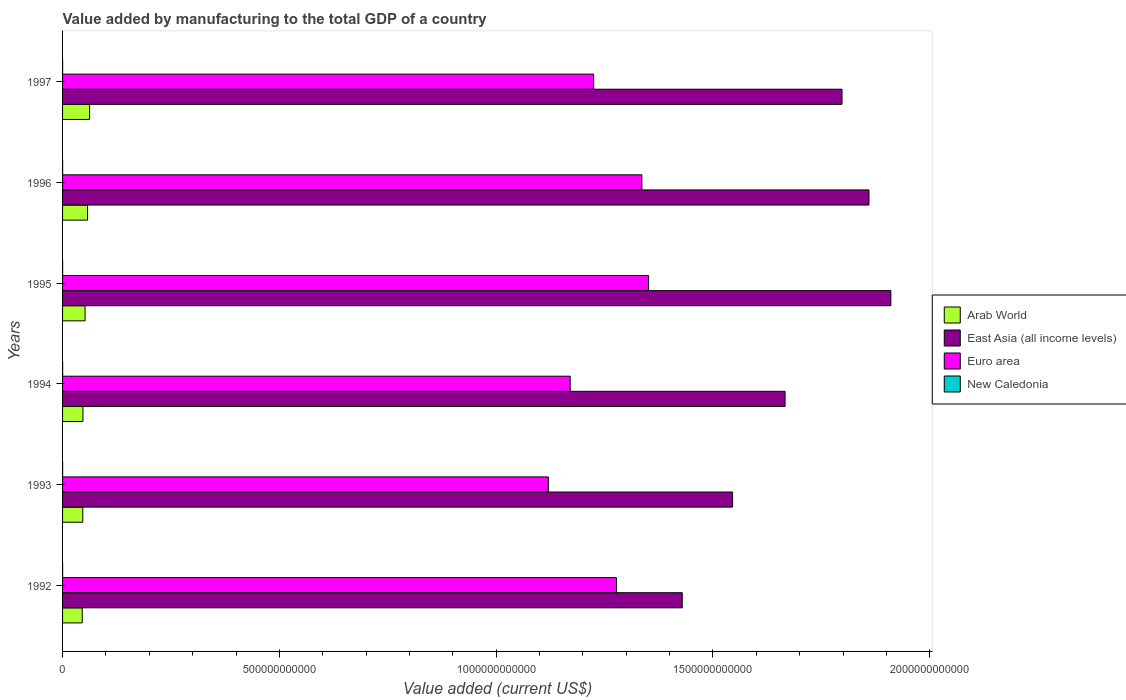How many different coloured bars are there?
Give a very brief answer. 4. How many groups of bars are there?
Offer a terse response. 6. Are the number of bars per tick equal to the number of legend labels?
Provide a short and direct response. Yes. How many bars are there on the 1st tick from the bottom?
Offer a terse response. 4. What is the label of the 1st group of bars from the top?
Your response must be concise. 1997. In how many cases, is the number of bars for a given year not equal to the number of legend labels?
Your answer should be very brief. 0. What is the value added by manufacturing to the total GDP in New Caledonia in 1995?
Give a very brief answer. 1.53e+08. Across all years, what is the maximum value added by manufacturing to the total GDP in New Caledonia?
Your response must be concise. 1.53e+08. Across all years, what is the minimum value added by manufacturing to the total GDP in East Asia (all income levels)?
Provide a short and direct response. 1.43e+12. In which year was the value added by manufacturing to the total GDP in Euro area maximum?
Offer a terse response. 1995. In which year was the value added by manufacturing to the total GDP in Arab World minimum?
Ensure brevity in your answer.  1992. What is the total value added by manufacturing to the total GDP in Arab World in the graph?
Your answer should be very brief. 3.11e+11. What is the difference between the value added by manufacturing to the total GDP in East Asia (all income levels) in 1995 and that in 1997?
Give a very brief answer. 1.13e+11. What is the difference between the value added by manufacturing to the total GDP in New Caledonia in 1993 and the value added by manufacturing to the total GDP in Euro area in 1995?
Keep it short and to the point. -1.35e+12. What is the average value added by manufacturing to the total GDP in Arab World per year?
Make the answer very short. 5.18e+1. In the year 1995, what is the difference between the value added by manufacturing to the total GDP in Arab World and value added by manufacturing to the total GDP in East Asia (all income levels)?
Provide a short and direct response. -1.86e+12. What is the ratio of the value added by manufacturing to the total GDP in East Asia (all income levels) in 1996 to that in 1997?
Offer a very short reply. 1.03. Is the difference between the value added by manufacturing to the total GDP in Arab World in 1995 and 1997 greater than the difference between the value added by manufacturing to the total GDP in East Asia (all income levels) in 1995 and 1997?
Ensure brevity in your answer.  No. What is the difference between the highest and the second highest value added by manufacturing to the total GDP in Arab World?
Your answer should be very brief. 4.71e+09. What is the difference between the highest and the lowest value added by manufacturing to the total GDP in East Asia (all income levels)?
Your answer should be very brief. 4.81e+11. In how many years, is the value added by manufacturing to the total GDP in Arab World greater than the average value added by manufacturing to the total GDP in Arab World taken over all years?
Give a very brief answer. 3. Is the sum of the value added by manufacturing to the total GDP in Arab World in 1993 and 1995 greater than the maximum value added by manufacturing to the total GDP in East Asia (all income levels) across all years?
Make the answer very short. No. What does the 3rd bar from the top in 1995 represents?
Provide a short and direct response. East Asia (all income levels). What does the 2nd bar from the bottom in 1997 represents?
Make the answer very short. East Asia (all income levels). Are all the bars in the graph horizontal?
Your answer should be very brief. Yes. What is the difference between two consecutive major ticks on the X-axis?
Give a very brief answer. 5.00e+11. Are the values on the major ticks of X-axis written in scientific E-notation?
Your answer should be compact. No. Does the graph contain any zero values?
Make the answer very short. No. Does the graph contain grids?
Provide a succinct answer. No. What is the title of the graph?
Make the answer very short. Value added by manufacturing to the total GDP of a country. What is the label or title of the X-axis?
Offer a terse response. Value added (current US$). What is the label or title of the Y-axis?
Offer a very short reply. Years. What is the Value added (current US$) in Arab World in 1992?
Your response must be concise. 4.54e+1. What is the Value added (current US$) in East Asia (all income levels) in 1992?
Offer a very short reply. 1.43e+12. What is the Value added (current US$) of Euro area in 1992?
Offer a very short reply. 1.28e+12. What is the Value added (current US$) of New Caledonia in 1992?
Make the answer very short. 1.42e+08. What is the Value added (current US$) in Arab World in 1993?
Keep it short and to the point. 4.66e+1. What is the Value added (current US$) in East Asia (all income levels) in 1993?
Give a very brief answer. 1.55e+12. What is the Value added (current US$) of Euro area in 1993?
Offer a very short reply. 1.12e+12. What is the Value added (current US$) of New Caledonia in 1993?
Provide a short and direct response. 1.44e+08. What is the Value added (current US$) in Arab World in 1994?
Make the answer very short. 4.70e+1. What is the Value added (current US$) in East Asia (all income levels) in 1994?
Your answer should be compact. 1.67e+12. What is the Value added (current US$) in Euro area in 1994?
Keep it short and to the point. 1.17e+12. What is the Value added (current US$) in New Caledonia in 1994?
Give a very brief answer. 1.40e+08. What is the Value added (current US$) in Arab World in 1995?
Keep it short and to the point. 5.19e+1. What is the Value added (current US$) in East Asia (all income levels) in 1995?
Provide a succinct answer. 1.91e+12. What is the Value added (current US$) of Euro area in 1995?
Make the answer very short. 1.35e+12. What is the Value added (current US$) in New Caledonia in 1995?
Your answer should be compact. 1.53e+08. What is the Value added (current US$) of Arab World in 1996?
Provide a short and direct response. 5.77e+1. What is the Value added (current US$) of East Asia (all income levels) in 1996?
Offer a very short reply. 1.86e+12. What is the Value added (current US$) of Euro area in 1996?
Keep it short and to the point. 1.34e+12. What is the Value added (current US$) in New Caledonia in 1996?
Provide a short and direct response. 1.43e+08. What is the Value added (current US$) in Arab World in 1997?
Your answer should be very brief. 6.24e+1. What is the Value added (current US$) in East Asia (all income levels) in 1997?
Offer a terse response. 1.80e+12. What is the Value added (current US$) of Euro area in 1997?
Give a very brief answer. 1.22e+12. What is the Value added (current US$) in New Caledonia in 1997?
Give a very brief answer. 1.30e+08. Across all years, what is the maximum Value added (current US$) of Arab World?
Provide a short and direct response. 6.24e+1. Across all years, what is the maximum Value added (current US$) in East Asia (all income levels)?
Your answer should be very brief. 1.91e+12. Across all years, what is the maximum Value added (current US$) of Euro area?
Provide a short and direct response. 1.35e+12. Across all years, what is the maximum Value added (current US$) of New Caledonia?
Offer a very short reply. 1.53e+08. Across all years, what is the minimum Value added (current US$) of Arab World?
Your response must be concise. 4.54e+1. Across all years, what is the minimum Value added (current US$) in East Asia (all income levels)?
Make the answer very short. 1.43e+12. Across all years, what is the minimum Value added (current US$) of Euro area?
Provide a succinct answer. 1.12e+12. Across all years, what is the minimum Value added (current US$) in New Caledonia?
Make the answer very short. 1.30e+08. What is the total Value added (current US$) of Arab World in the graph?
Your response must be concise. 3.11e+11. What is the total Value added (current US$) of East Asia (all income levels) in the graph?
Give a very brief answer. 1.02e+13. What is the total Value added (current US$) in Euro area in the graph?
Offer a terse response. 7.48e+12. What is the total Value added (current US$) of New Caledonia in the graph?
Ensure brevity in your answer.  8.52e+08. What is the difference between the Value added (current US$) of Arab World in 1992 and that in 1993?
Keep it short and to the point. -1.29e+09. What is the difference between the Value added (current US$) in East Asia (all income levels) in 1992 and that in 1993?
Provide a short and direct response. -1.16e+11. What is the difference between the Value added (current US$) in Euro area in 1992 and that in 1993?
Ensure brevity in your answer.  1.57e+11. What is the difference between the Value added (current US$) of New Caledonia in 1992 and that in 1993?
Offer a terse response. -2.42e+06. What is the difference between the Value added (current US$) in Arab World in 1992 and that in 1994?
Give a very brief answer. -1.65e+09. What is the difference between the Value added (current US$) in East Asia (all income levels) in 1992 and that in 1994?
Make the answer very short. -2.37e+11. What is the difference between the Value added (current US$) of Euro area in 1992 and that in 1994?
Offer a terse response. 1.07e+11. What is the difference between the Value added (current US$) of New Caledonia in 1992 and that in 1994?
Your answer should be very brief. 1.45e+06. What is the difference between the Value added (current US$) in Arab World in 1992 and that in 1995?
Make the answer very short. -6.56e+09. What is the difference between the Value added (current US$) in East Asia (all income levels) in 1992 and that in 1995?
Provide a short and direct response. -4.81e+11. What is the difference between the Value added (current US$) in Euro area in 1992 and that in 1995?
Your response must be concise. -7.39e+1. What is the difference between the Value added (current US$) in New Caledonia in 1992 and that in 1995?
Provide a succinct answer. -1.15e+07. What is the difference between the Value added (current US$) of Arab World in 1992 and that in 1996?
Your answer should be very brief. -1.23e+1. What is the difference between the Value added (current US$) of East Asia (all income levels) in 1992 and that in 1996?
Keep it short and to the point. -4.31e+11. What is the difference between the Value added (current US$) of Euro area in 1992 and that in 1996?
Your answer should be compact. -5.85e+1. What is the difference between the Value added (current US$) of New Caledonia in 1992 and that in 1996?
Make the answer very short. -1.44e+06. What is the difference between the Value added (current US$) of Arab World in 1992 and that in 1997?
Give a very brief answer. -1.70e+1. What is the difference between the Value added (current US$) in East Asia (all income levels) in 1992 and that in 1997?
Give a very brief answer. -3.68e+11. What is the difference between the Value added (current US$) in Euro area in 1992 and that in 1997?
Give a very brief answer. 5.28e+1. What is the difference between the Value added (current US$) in New Caledonia in 1992 and that in 1997?
Offer a terse response. 1.13e+07. What is the difference between the Value added (current US$) of Arab World in 1993 and that in 1994?
Offer a very short reply. -3.62e+08. What is the difference between the Value added (current US$) in East Asia (all income levels) in 1993 and that in 1994?
Your response must be concise. -1.21e+11. What is the difference between the Value added (current US$) in Euro area in 1993 and that in 1994?
Offer a very short reply. -5.04e+1. What is the difference between the Value added (current US$) in New Caledonia in 1993 and that in 1994?
Your response must be concise. 3.86e+06. What is the difference between the Value added (current US$) of Arab World in 1993 and that in 1995?
Your answer should be compact. -5.28e+09. What is the difference between the Value added (current US$) of East Asia (all income levels) in 1993 and that in 1995?
Your response must be concise. -3.65e+11. What is the difference between the Value added (current US$) of Euro area in 1993 and that in 1995?
Make the answer very short. -2.31e+11. What is the difference between the Value added (current US$) of New Caledonia in 1993 and that in 1995?
Your response must be concise. -9.07e+06. What is the difference between the Value added (current US$) in Arab World in 1993 and that in 1996?
Your answer should be very brief. -1.10e+1. What is the difference between the Value added (current US$) of East Asia (all income levels) in 1993 and that in 1996?
Provide a succinct answer. -3.14e+11. What is the difference between the Value added (current US$) of Euro area in 1993 and that in 1996?
Offer a very short reply. -2.16e+11. What is the difference between the Value added (current US$) of New Caledonia in 1993 and that in 1996?
Make the answer very short. 9.72e+05. What is the difference between the Value added (current US$) of Arab World in 1993 and that in 1997?
Provide a succinct answer. -1.57e+1. What is the difference between the Value added (current US$) of East Asia (all income levels) in 1993 and that in 1997?
Offer a terse response. -2.52e+11. What is the difference between the Value added (current US$) in Euro area in 1993 and that in 1997?
Provide a succinct answer. -1.04e+11. What is the difference between the Value added (current US$) in New Caledonia in 1993 and that in 1997?
Give a very brief answer. 1.38e+07. What is the difference between the Value added (current US$) of Arab World in 1994 and that in 1995?
Provide a short and direct response. -4.92e+09. What is the difference between the Value added (current US$) of East Asia (all income levels) in 1994 and that in 1995?
Your response must be concise. -2.44e+11. What is the difference between the Value added (current US$) of Euro area in 1994 and that in 1995?
Provide a succinct answer. -1.81e+11. What is the difference between the Value added (current US$) of New Caledonia in 1994 and that in 1995?
Your response must be concise. -1.29e+07. What is the difference between the Value added (current US$) in Arab World in 1994 and that in 1996?
Your response must be concise. -1.07e+1. What is the difference between the Value added (current US$) of East Asia (all income levels) in 1994 and that in 1996?
Provide a short and direct response. -1.93e+11. What is the difference between the Value added (current US$) of Euro area in 1994 and that in 1996?
Make the answer very short. -1.65e+11. What is the difference between the Value added (current US$) in New Caledonia in 1994 and that in 1996?
Provide a succinct answer. -2.89e+06. What is the difference between the Value added (current US$) in Arab World in 1994 and that in 1997?
Your answer should be very brief. -1.54e+1. What is the difference between the Value added (current US$) in East Asia (all income levels) in 1994 and that in 1997?
Ensure brevity in your answer.  -1.31e+11. What is the difference between the Value added (current US$) of Euro area in 1994 and that in 1997?
Your answer should be very brief. -5.40e+1. What is the difference between the Value added (current US$) of New Caledonia in 1994 and that in 1997?
Keep it short and to the point. 9.89e+06. What is the difference between the Value added (current US$) in Arab World in 1995 and that in 1996?
Keep it short and to the point. -5.74e+09. What is the difference between the Value added (current US$) in East Asia (all income levels) in 1995 and that in 1996?
Ensure brevity in your answer.  5.05e+1. What is the difference between the Value added (current US$) of Euro area in 1995 and that in 1996?
Provide a succinct answer. 1.54e+1. What is the difference between the Value added (current US$) in New Caledonia in 1995 and that in 1996?
Offer a very short reply. 1.00e+07. What is the difference between the Value added (current US$) in Arab World in 1995 and that in 1997?
Make the answer very short. -1.05e+1. What is the difference between the Value added (current US$) in East Asia (all income levels) in 1995 and that in 1997?
Give a very brief answer. 1.13e+11. What is the difference between the Value added (current US$) in Euro area in 1995 and that in 1997?
Provide a succinct answer. 1.27e+11. What is the difference between the Value added (current US$) of New Caledonia in 1995 and that in 1997?
Your answer should be compact. 2.28e+07. What is the difference between the Value added (current US$) of Arab World in 1996 and that in 1997?
Your answer should be very brief. -4.71e+09. What is the difference between the Value added (current US$) of East Asia (all income levels) in 1996 and that in 1997?
Your response must be concise. 6.21e+1. What is the difference between the Value added (current US$) of Euro area in 1996 and that in 1997?
Your answer should be compact. 1.11e+11. What is the difference between the Value added (current US$) in New Caledonia in 1996 and that in 1997?
Your answer should be very brief. 1.28e+07. What is the difference between the Value added (current US$) of Arab World in 1992 and the Value added (current US$) of East Asia (all income levels) in 1993?
Your answer should be compact. -1.50e+12. What is the difference between the Value added (current US$) of Arab World in 1992 and the Value added (current US$) of Euro area in 1993?
Provide a short and direct response. -1.08e+12. What is the difference between the Value added (current US$) in Arab World in 1992 and the Value added (current US$) in New Caledonia in 1993?
Make the answer very short. 4.52e+1. What is the difference between the Value added (current US$) of East Asia (all income levels) in 1992 and the Value added (current US$) of Euro area in 1993?
Your answer should be compact. 3.09e+11. What is the difference between the Value added (current US$) of East Asia (all income levels) in 1992 and the Value added (current US$) of New Caledonia in 1993?
Your answer should be compact. 1.43e+12. What is the difference between the Value added (current US$) in Euro area in 1992 and the Value added (current US$) in New Caledonia in 1993?
Your response must be concise. 1.28e+12. What is the difference between the Value added (current US$) of Arab World in 1992 and the Value added (current US$) of East Asia (all income levels) in 1994?
Your answer should be very brief. -1.62e+12. What is the difference between the Value added (current US$) of Arab World in 1992 and the Value added (current US$) of Euro area in 1994?
Keep it short and to the point. -1.13e+12. What is the difference between the Value added (current US$) in Arab World in 1992 and the Value added (current US$) in New Caledonia in 1994?
Offer a terse response. 4.52e+1. What is the difference between the Value added (current US$) of East Asia (all income levels) in 1992 and the Value added (current US$) of Euro area in 1994?
Ensure brevity in your answer.  2.58e+11. What is the difference between the Value added (current US$) of East Asia (all income levels) in 1992 and the Value added (current US$) of New Caledonia in 1994?
Ensure brevity in your answer.  1.43e+12. What is the difference between the Value added (current US$) in Euro area in 1992 and the Value added (current US$) in New Caledonia in 1994?
Provide a short and direct response. 1.28e+12. What is the difference between the Value added (current US$) of Arab World in 1992 and the Value added (current US$) of East Asia (all income levels) in 1995?
Your answer should be very brief. -1.86e+12. What is the difference between the Value added (current US$) of Arab World in 1992 and the Value added (current US$) of Euro area in 1995?
Keep it short and to the point. -1.31e+12. What is the difference between the Value added (current US$) in Arab World in 1992 and the Value added (current US$) in New Caledonia in 1995?
Make the answer very short. 4.52e+1. What is the difference between the Value added (current US$) of East Asia (all income levels) in 1992 and the Value added (current US$) of Euro area in 1995?
Offer a very short reply. 7.77e+1. What is the difference between the Value added (current US$) of East Asia (all income levels) in 1992 and the Value added (current US$) of New Caledonia in 1995?
Keep it short and to the point. 1.43e+12. What is the difference between the Value added (current US$) in Euro area in 1992 and the Value added (current US$) in New Caledonia in 1995?
Your response must be concise. 1.28e+12. What is the difference between the Value added (current US$) of Arab World in 1992 and the Value added (current US$) of East Asia (all income levels) in 1996?
Ensure brevity in your answer.  -1.81e+12. What is the difference between the Value added (current US$) of Arab World in 1992 and the Value added (current US$) of Euro area in 1996?
Give a very brief answer. -1.29e+12. What is the difference between the Value added (current US$) in Arab World in 1992 and the Value added (current US$) in New Caledonia in 1996?
Your answer should be compact. 4.52e+1. What is the difference between the Value added (current US$) of East Asia (all income levels) in 1992 and the Value added (current US$) of Euro area in 1996?
Ensure brevity in your answer.  9.31e+1. What is the difference between the Value added (current US$) of East Asia (all income levels) in 1992 and the Value added (current US$) of New Caledonia in 1996?
Offer a terse response. 1.43e+12. What is the difference between the Value added (current US$) in Euro area in 1992 and the Value added (current US$) in New Caledonia in 1996?
Your response must be concise. 1.28e+12. What is the difference between the Value added (current US$) of Arab World in 1992 and the Value added (current US$) of East Asia (all income levels) in 1997?
Your answer should be very brief. -1.75e+12. What is the difference between the Value added (current US$) in Arab World in 1992 and the Value added (current US$) in Euro area in 1997?
Offer a very short reply. -1.18e+12. What is the difference between the Value added (current US$) in Arab World in 1992 and the Value added (current US$) in New Caledonia in 1997?
Your answer should be compact. 4.52e+1. What is the difference between the Value added (current US$) in East Asia (all income levels) in 1992 and the Value added (current US$) in Euro area in 1997?
Offer a very short reply. 2.04e+11. What is the difference between the Value added (current US$) in East Asia (all income levels) in 1992 and the Value added (current US$) in New Caledonia in 1997?
Your response must be concise. 1.43e+12. What is the difference between the Value added (current US$) of Euro area in 1992 and the Value added (current US$) of New Caledonia in 1997?
Your answer should be very brief. 1.28e+12. What is the difference between the Value added (current US$) of Arab World in 1993 and the Value added (current US$) of East Asia (all income levels) in 1994?
Keep it short and to the point. -1.62e+12. What is the difference between the Value added (current US$) in Arab World in 1993 and the Value added (current US$) in Euro area in 1994?
Offer a terse response. -1.12e+12. What is the difference between the Value added (current US$) of Arab World in 1993 and the Value added (current US$) of New Caledonia in 1994?
Offer a very short reply. 4.65e+1. What is the difference between the Value added (current US$) in East Asia (all income levels) in 1993 and the Value added (current US$) in Euro area in 1994?
Your answer should be very brief. 3.75e+11. What is the difference between the Value added (current US$) of East Asia (all income levels) in 1993 and the Value added (current US$) of New Caledonia in 1994?
Make the answer very short. 1.55e+12. What is the difference between the Value added (current US$) in Euro area in 1993 and the Value added (current US$) in New Caledonia in 1994?
Offer a terse response. 1.12e+12. What is the difference between the Value added (current US$) in Arab World in 1993 and the Value added (current US$) in East Asia (all income levels) in 1995?
Provide a succinct answer. -1.86e+12. What is the difference between the Value added (current US$) in Arab World in 1993 and the Value added (current US$) in Euro area in 1995?
Give a very brief answer. -1.30e+12. What is the difference between the Value added (current US$) of Arab World in 1993 and the Value added (current US$) of New Caledonia in 1995?
Your response must be concise. 4.65e+1. What is the difference between the Value added (current US$) in East Asia (all income levels) in 1993 and the Value added (current US$) in Euro area in 1995?
Your answer should be very brief. 1.94e+11. What is the difference between the Value added (current US$) in East Asia (all income levels) in 1993 and the Value added (current US$) in New Caledonia in 1995?
Your response must be concise. 1.55e+12. What is the difference between the Value added (current US$) of Euro area in 1993 and the Value added (current US$) of New Caledonia in 1995?
Your answer should be compact. 1.12e+12. What is the difference between the Value added (current US$) of Arab World in 1993 and the Value added (current US$) of East Asia (all income levels) in 1996?
Your response must be concise. -1.81e+12. What is the difference between the Value added (current US$) in Arab World in 1993 and the Value added (current US$) in Euro area in 1996?
Your answer should be very brief. -1.29e+12. What is the difference between the Value added (current US$) in Arab World in 1993 and the Value added (current US$) in New Caledonia in 1996?
Offer a terse response. 4.65e+1. What is the difference between the Value added (current US$) in East Asia (all income levels) in 1993 and the Value added (current US$) in Euro area in 1996?
Provide a short and direct response. 2.09e+11. What is the difference between the Value added (current US$) of East Asia (all income levels) in 1993 and the Value added (current US$) of New Caledonia in 1996?
Give a very brief answer. 1.55e+12. What is the difference between the Value added (current US$) of Euro area in 1993 and the Value added (current US$) of New Caledonia in 1996?
Provide a short and direct response. 1.12e+12. What is the difference between the Value added (current US$) in Arab World in 1993 and the Value added (current US$) in East Asia (all income levels) in 1997?
Offer a very short reply. -1.75e+12. What is the difference between the Value added (current US$) in Arab World in 1993 and the Value added (current US$) in Euro area in 1997?
Give a very brief answer. -1.18e+12. What is the difference between the Value added (current US$) of Arab World in 1993 and the Value added (current US$) of New Caledonia in 1997?
Provide a short and direct response. 4.65e+1. What is the difference between the Value added (current US$) of East Asia (all income levels) in 1993 and the Value added (current US$) of Euro area in 1997?
Provide a short and direct response. 3.21e+11. What is the difference between the Value added (current US$) of East Asia (all income levels) in 1993 and the Value added (current US$) of New Caledonia in 1997?
Make the answer very short. 1.55e+12. What is the difference between the Value added (current US$) in Euro area in 1993 and the Value added (current US$) in New Caledonia in 1997?
Give a very brief answer. 1.12e+12. What is the difference between the Value added (current US$) of Arab World in 1994 and the Value added (current US$) of East Asia (all income levels) in 1995?
Keep it short and to the point. -1.86e+12. What is the difference between the Value added (current US$) in Arab World in 1994 and the Value added (current US$) in Euro area in 1995?
Keep it short and to the point. -1.30e+12. What is the difference between the Value added (current US$) of Arab World in 1994 and the Value added (current US$) of New Caledonia in 1995?
Keep it short and to the point. 4.69e+1. What is the difference between the Value added (current US$) of East Asia (all income levels) in 1994 and the Value added (current US$) of Euro area in 1995?
Offer a very short reply. 3.15e+11. What is the difference between the Value added (current US$) in East Asia (all income levels) in 1994 and the Value added (current US$) in New Caledonia in 1995?
Keep it short and to the point. 1.67e+12. What is the difference between the Value added (current US$) of Euro area in 1994 and the Value added (current US$) of New Caledonia in 1995?
Provide a short and direct response. 1.17e+12. What is the difference between the Value added (current US$) in Arab World in 1994 and the Value added (current US$) in East Asia (all income levels) in 1996?
Give a very brief answer. -1.81e+12. What is the difference between the Value added (current US$) of Arab World in 1994 and the Value added (current US$) of Euro area in 1996?
Give a very brief answer. -1.29e+12. What is the difference between the Value added (current US$) in Arab World in 1994 and the Value added (current US$) in New Caledonia in 1996?
Keep it short and to the point. 4.69e+1. What is the difference between the Value added (current US$) of East Asia (all income levels) in 1994 and the Value added (current US$) of Euro area in 1996?
Ensure brevity in your answer.  3.30e+11. What is the difference between the Value added (current US$) of East Asia (all income levels) in 1994 and the Value added (current US$) of New Caledonia in 1996?
Offer a very short reply. 1.67e+12. What is the difference between the Value added (current US$) of Euro area in 1994 and the Value added (current US$) of New Caledonia in 1996?
Make the answer very short. 1.17e+12. What is the difference between the Value added (current US$) of Arab World in 1994 and the Value added (current US$) of East Asia (all income levels) in 1997?
Provide a short and direct response. -1.75e+12. What is the difference between the Value added (current US$) of Arab World in 1994 and the Value added (current US$) of Euro area in 1997?
Keep it short and to the point. -1.18e+12. What is the difference between the Value added (current US$) in Arab World in 1994 and the Value added (current US$) in New Caledonia in 1997?
Your answer should be compact. 4.69e+1. What is the difference between the Value added (current US$) in East Asia (all income levels) in 1994 and the Value added (current US$) in Euro area in 1997?
Ensure brevity in your answer.  4.42e+11. What is the difference between the Value added (current US$) in East Asia (all income levels) in 1994 and the Value added (current US$) in New Caledonia in 1997?
Offer a very short reply. 1.67e+12. What is the difference between the Value added (current US$) in Euro area in 1994 and the Value added (current US$) in New Caledonia in 1997?
Offer a very short reply. 1.17e+12. What is the difference between the Value added (current US$) in Arab World in 1995 and the Value added (current US$) in East Asia (all income levels) in 1996?
Keep it short and to the point. -1.81e+12. What is the difference between the Value added (current US$) in Arab World in 1995 and the Value added (current US$) in Euro area in 1996?
Offer a terse response. -1.28e+12. What is the difference between the Value added (current US$) of Arab World in 1995 and the Value added (current US$) of New Caledonia in 1996?
Offer a very short reply. 5.18e+1. What is the difference between the Value added (current US$) in East Asia (all income levels) in 1995 and the Value added (current US$) in Euro area in 1996?
Provide a succinct answer. 5.74e+11. What is the difference between the Value added (current US$) of East Asia (all income levels) in 1995 and the Value added (current US$) of New Caledonia in 1996?
Your answer should be very brief. 1.91e+12. What is the difference between the Value added (current US$) of Euro area in 1995 and the Value added (current US$) of New Caledonia in 1996?
Give a very brief answer. 1.35e+12. What is the difference between the Value added (current US$) of Arab World in 1995 and the Value added (current US$) of East Asia (all income levels) in 1997?
Keep it short and to the point. -1.75e+12. What is the difference between the Value added (current US$) of Arab World in 1995 and the Value added (current US$) of Euro area in 1997?
Your response must be concise. -1.17e+12. What is the difference between the Value added (current US$) of Arab World in 1995 and the Value added (current US$) of New Caledonia in 1997?
Your response must be concise. 5.18e+1. What is the difference between the Value added (current US$) in East Asia (all income levels) in 1995 and the Value added (current US$) in Euro area in 1997?
Provide a short and direct response. 6.85e+11. What is the difference between the Value added (current US$) of East Asia (all income levels) in 1995 and the Value added (current US$) of New Caledonia in 1997?
Provide a succinct answer. 1.91e+12. What is the difference between the Value added (current US$) of Euro area in 1995 and the Value added (current US$) of New Caledonia in 1997?
Provide a succinct answer. 1.35e+12. What is the difference between the Value added (current US$) in Arab World in 1996 and the Value added (current US$) in East Asia (all income levels) in 1997?
Give a very brief answer. -1.74e+12. What is the difference between the Value added (current US$) in Arab World in 1996 and the Value added (current US$) in Euro area in 1997?
Offer a very short reply. -1.17e+12. What is the difference between the Value added (current US$) of Arab World in 1996 and the Value added (current US$) of New Caledonia in 1997?
Your answer should be compact. 5.75e+1. What is the difference between the Value added (current US$) in East Asia (all income levels) in 1996 and the Value added (current US$) in Euro area in 1997?
Provide a short and direct response. 6.35e+11. What is the difference between the Value added (current US$) of East Asia (all income levels) in 1996 and the Value added (current US$) of New Caledonia in 1997?
Give a very brief answer. 1.86e+12. What is the difference between the Value added (current US$) in Euro area in 1996 and the Value added (current US$) in New Caledonia in 1997?
Provide a short and direct response. 1.34e+12. What is the average Value added (current US$) of Arab World per year?
Your answer should be compact. 5.18e+1. What is the average Value added (current US$) of East Asia (all income levels) per year?
Offer a very short reply. 1.70e+12. What is the average Value added (current US$) in Euro area per year?
Your answer should be compact. 1.25e+12. What is the average Value added (current US$) in New Caledonia per year?
Ensure brevity in your answer.  1.42e+08. In the year 1992, what is the difference between the Value added (current US$) in Arab World and Value added (current US$) in East Asia (all income levels)?
Keep it short and to the point. -1.38e+12. In the year 1992, what is the difference between the Value added (current US$) of Arab World and Value added (current US$) of Euro area?
Provide a short and direct response. -1.23e+12. In the year 1992, what is the difference between the Value added (current US$) of Arab World and Value added (current US$) of New Caledonia?
Offer a terse response. 4.52e+1. In the year 1992, what is the difference between the Value added (current US$) of East Asia (all income levels) and Value added (current US$) of Euro area?
Give a very brief answer. 1.52e+11. In the year 1992, what is the difference between the Value added (current US$) in East Asia (all income levels) and Value added (current US$) in New Caledonia?
Ensure brevity in your answer.  1.43e+12. In the year 1992, what is the difference between the Value added (current US$) of Euro area and Value added (current US$) of New Caledonia?
Make the answer very short. 1.28e+12. In the year 1993, what is the difference between the Value added (current US$) in Arab World and Value added (current US$) in East Asia (all income levels)?
Make the answer very short. -1.50e+12. In the year 1993, what is the difference between the Value added (current US$) in Arab World and Value added (current US$) in Euro area?
Make the answer very short. -1.07e+12. In the year 1993, what is the difference between the Value added (current US$) of Arab World and Value added (current US$) of New Caledonia?
Give a very brief answer. 4.65e+1. In the year 1993, what is the difference between the Value added (current US$) of East Asia (all income levels) and Value added (current US$) of Euro area?
Provide a short and direct response. 4.25e+11. In the year 1993, what is the difference between the Value added (current US$) in East Asia (all income levels) and Value added (current US$) in New Caledonia?
Give a very brief answer. 1.55e+12. In the year 1993, what is the difference between the Value added (current US$) of Euro area and Value added (current US$) of New Caledonia?
Provide a short and direct response. 1.12e+12. In the year 1994, what is the difference between the Value added (current US$) in Arab World and Value added (current US$) in East Asia (all income levels)?
Offer a terse response. -1.62e+12. In the year 1994, what is the difference between the Value added (current US$) in Arab World and Value added (current US$) in Euro area?
Ensure brevity in your answer.  -1.12e+12. In the year 1994, what is the difference between the Value added (current US$) in Arab World and Value added (current US$) in New Caledonia?
Keep it short and to the point. 4.69e+1. In the year 1994, what is the difference between the Value added (current US$) of East Asia (all income levels) and Value added (current US$) of Euro area?
Give a very brief answer. 4.96e+11. In the year 1994, what is the difference between the Value added (current US$) in East Asia (all income levels) and Value added (current US$) in New Caledonia?
Your answer should be compact. 1.67e+12. In the year 1994, what is the difference between the Value added (current US$) of Euro area and Value added (current US$) of New Caledonia?
Offer a very short reply. 1.17e+12. In the year 1995, what is the difference between the Value added (current US$) of Arab World and Value added (current US$) of East Asia (all income levels)?
Give a very brief answer. -1.86e+12. In the year 1995, what is the difference between the Value added (current US$) of Arab World and Value added (current US$) of Euro area?
Ensure brevity in your answer.  -1.30e+12. In the year 1995, what is the difference between the Value added (current US$) in Arab World and Value added (current US$) in New Caledonia?
Offer a terse response. 5.18e+1. In the year 1995, what is the difference between the Value added (current US$) in East Asia (all income levels) and Value added (current US$) in Euro area?
Offer a terse response. 5.59e+11. In the year 1995, what is the difference between the Value added (current US$) in East Asia (all income levels) and Value added (current US$) in New Caledonia?
Your answer should be compact. 1.91e+12. In the year 1995, what is the difference between the Value added (current US$) of Euro area and Value added (current US$) of New Caledonia?
Your response must be concise. 1.35e+12. In the year 1996, what is the difference between the Value added (current US$) in Arab World and Value added (current US$) in East Asia (all income levels)?
Offer a very short reply. -1.80e+12. In the year 1996, what is the difference between the Value added (current US$) of Arab World and Value added (current US$) of Euro area?
Offer a terse response. -1.28e+12. In the year 1996, what is the difference between the Value added (current US$) in Arab World and Value added (current US$) in New Caledonia?
Keep it short and to the point. 5.75e+1. In the year 1996, what is the difference between the Value added (current US$) in East Asia (all income levels) and Value added (current US$) in Euro area?
Your answer should be compact. 5.24e+11. In the year 1996, what is the difference between the Value added (current US$) in East Asia (all income levels) and Value added (current US$) in New Caledonia?
Offer a terse response. 1.86e+12. In the year 1996, what is the difference between the Value added (current US$) of Euro area and Value added (current US$) of New Caledonia?
Keep it short and to the point. 1.34e+12. In the year 1997, what is the difference between the Value added (current US$) of Arab World and Value added (current US$) of East Asia (all income levels)?
Provide a short and direct response. -1.74e+12. In the year 1997, what is the difference between the Value added (current US$) in Arab World and Value added (current US$) in Euro area?
Your answer should be very brief. -1.16e+12. In the year 1997, what is the difference between the Value added (current US$) of Arab World and Value added (current US$) of New Caledonia?
Give a very brief answer. 6.22e+1. In the year 1997, what is the difference between the Value added (current US$) of East Asia (all income levels) and Value added (current US$) of Euro area?
Ensure brevity in your answer.  5.73e+11. In the year 1997, what is the difference between the Value added (current US$) of East Asia (all income levels) and Value added (current US$) of New Caledonia?
Ensure brevity in your answer.  1.80e+12. In the year 1997, what is the difference between the Value added (current US$) of Euro area and Value added (current US$) of New Caledonia?
Ensure brevity in your answer.  1.22e+12. What is the ratio of the Value added (current US$) in Arab World in 1992 to that in 1993?
Ensure brevity in your answer.  0.97. What is the ratio of the Value added (current US$) in East Asia (all income levels) in 1992 to that in 1993?
Provide a succinct answer. 0.92. What is the ratio of the Value added (current US$) of Euro area in 1992 to that in 1993?
Provide a succinct answer. 1.14. What is the ratio of the Value added (current US$) in New Caledonia in 1992 to that in 1993?
Your answer should be compact. 0.98. What is the ratio of the Value added (current US$) in Arab World in 1992 to that in 1994?
Offer a very short reply. 0.96. What is the ratio of the Value added (current US$) of East Asia (all income levels) in 1992 to that in 1994?
Your answer should be very brief. 0.86. What is the ratio of the Value added (current US$) in Euro area in 1992 to that in 1994?
Ensure brevity in your answer.  1.09. What is the ratio of the Value added (current US$) of New Caledonia in 1992 to that in 1994?
Give a very brief answer. 1.01. What is the ratio of the Value added (current US$) of Arab World in 1992 to that in 1995?
Provide a short and direct response. 0.87. What is the ratio of the Value added (current US$) of East Asia (all income levels) in 1992 to that in 1995?
Your response must be concise. 0.75. What is the ratio of the Value added (current US$) in Euro area in 1992 to that in 1995?
Offer a very short reply. 0.95. What is the ratio of the Value added (current US$) of New Caledonia in 1992 to that in 1995?
Keep it short and to the point. 0.92. What is the ratio of the Value added (current US$) in Arab World in 1992 to that in 1996?
Give a very brief answer. 0.79. What is the ratio of the Value added (current US$) of East Asia (all income levels) in 1992 to that in 1996?
Give a very brief answer. 0.77. What is the ratio of the Value added (current US$) of Euro area in 1992 to that in 1996?
Offer a very short reply. 0.96. What is the ratio of the Value added (current US$) of Arab World in 1992 to that in 1997?
Make the answer very short. 0.73. What is the ratio of the Value added (current US$) in East Asia (all income levels) in 1992 to that in 1997?
Give a very brief answer. 0.8. What is the ratio of the Value added (current US$) of Euro area in 1992 to that in 1997?
Provide a succinct answer. 1.04. What is the ratio of the Value added (current US$) of New Caledonia in 1992 to that in 1997?
Your answer should be compact. 1.09. What is the ratio of the Value added (current US$) in East Asia (all income levels) in 1993 to that in 1994?
Offer a terse response. 0.93. What is the ratio of the Value added (current US$) in New Caledonia in 1993 to that in 1994?
Your answer should be very brief. 1.03. What is the ratio of the Value added (current US$) in Arab World in 1993 to that in 1995?
Provide a short and direct response. 0.9. What is the ratio of the Value added (current US$) in East Asia (all income levels) in 1993 to that in 1995?
Provide a succinct answer. 0.81. What is the ratio of the Value added (current US$) in Euro area in 1993 to that in 1995?
Your answer should be very brief. 0.83. What is the ratio of the Value added (current US$) in New Caledonia in 1993 to that in 1995?
Give a very brief answer. 0.94. What is the ratio of the Value added (current US$) in Arab World in 1993 to that in 1996?
Your response must be concise. 0.81. What is the ratio of the Value added (current US$) in East Asia (all income levels) in 1993 to that in 1996?
Offer a very short reply. 0.83. What is the ratio of the Value added (current US$) of Euro area in 1993 to that in 1996?
Your answer should be compact. 0.84. What is the ratio of the Value added (current US$) of New Caledonia in 1993 to that in 1996?
Your answer should be very brief. 1.01. What is the ratio of the Value added (current US$) in Arab World in 1993 to that in 1997?
Keep it short and to the point. 0.75. What is the ratio of the Value added (current US$) of East Asia (all income levels) in 1993 to that in 1997?
Offer a terse response. 0.86. What is the ratio of the Value added (current US$) in Euro area in 1993 to that in 1997?
Your answer should be very brief. 0.91. What is the ratio of the Value added (current US$) in New Caledonia in 1993 to that in 1997?
Provide a short and direct response. 1.11. What is the ratio of the Value added (current US$) in Arab World in 1994 to that in 1995?
Offer a terse response. 0.91. What is the ratio of the Value added (current US$) in East Asia (all income levels) in 1994 to that in 1995?
Offer a very short reply. 0.87. What is the ratio of the Value added (current US$) in Euro area in 1994 to that in 1995?
Your answer should be very brief. 0.87. What is the ratio of the Value added (current US$) of New Caledonia in 1994 to that in 1995?
Provide a short and direct response. 0.92. What is the ratio of the Value added (current US$) of Arab World in 1994 to that in 1996?
Keep it short and to the point. 0.82. What is the ratio of the Value added (current US$) in East Asia (all income levels) in 1994 to that in 1996?
Make the answer very short. 0.9. What is the ratio of the Value added (current US$) in Euro area in 1994 to that in 1996?
Offer a terse response. 0.88. What is the ratio of the Value added (current US$) in New Caledonia in 1994 to that in 1996?
Keep it short and to the point. 0.98. What is the ratio of the Value added (current US$) in Arab World in 1994 to that in 1997?
Make the answer very short. 0.75. What is the ratio of the Value added (current US$) in East Asia (all income levels) in 1994 to that in 1997?
Provide a succinct answer. 0.93. What is the ratio of the Value added (current US$) of Euro area in 1994 to that in 1997?
Provide a short and direct response. 0.96. What is the ratio of the Value added (current US$) in New Caledonia in 1994 to that in 1997?
Offer a very short reply. 1.08. What is the ratio of the Value added (current US$) in Arab World in 1995 to that in 1996?
Provide a succinct answer. 0.9. What is the ratio of the Value added (current US$) in East Asia (all income levels) in 1995 to that in 1996?
Provide a succinct answer. 1.03. What is the ratio of the Value added (current US$) of Euro area in 1995 to that in 1996?
Give a very brief answer. 1.01. What is the ratio of the Value added (current US$) in New Caledonia in 1995 to that in 1996?
Your response must be concise. 1.07. What is the ratio of the Value added (current US$) in Arab World in 1995 to that in 1997?
Offer a very short reply. 0.83. What is the ratio of the Value added (current US$) of East Asia (all income levels) in 1995 to that in 1997?
Offer a very short reply. 1.06. What is the ratio of the Value added (current US$) of Euro area in 1995 to that in 1997?
Offer a terse response. 1.1. What is the ratio of the Value added (current US$) in New Caledonia in 1995 to that in 1997?
Your answer should be very brief. 1.18. What is the ratio of the Value added (current US$) of Arab World in 1996 to that in 1997?
Your answer should be compact. 0.92. What is the ratio of the Value added (current US$) of East Asia (all income levels) in 1996 to that in 1997?
Your answer should be compact. 1.03. What is the ratio of the Value added (current US$) of New Caledonia in 1996 to that in 1997?
Your response must be concise. 1.1. What is the difference between the highest and the second highest Value added (current US$) in Arab World?
Provide a short and direct response. 4.71e+09. What is the difference between the highest and the second highest Value added (current US$) in East Asia (all income levels)?
Provide a succinct answer. 5.05e+1. What is the difference between the highest and the second highest Value added (current US$) of Euro area?
Ensure brevity in your answer.  1.54e+1. What is the difference between the highest and the second highest Value added (current US$) of New Caledonia?
Provide a short and direct response. 9.07e+06. What is the difference between the highest and the lowest Value added (current US$) in Arab World?
Provide a succinct answer. 1.70e+1. What is the difference between the highest and the lowest Value added (current US$) of East Asia (all income levels)?
Provide a succinct answer. 4.81e+11. What is the difference between the highest and the lowest Value added (current US$) of Euro area?
Make the answer very short. 2.31e+11. What is the difference between the highest and the lowest Value added (current US$) of New Caledonia?
Give a very brief answer. 2.28e+07. 